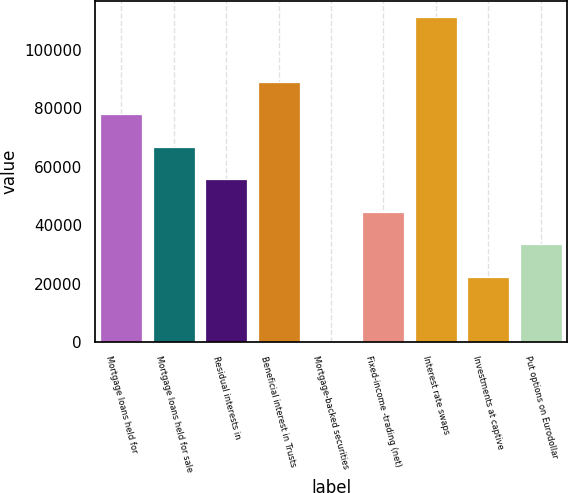Convert chart. <chart><loc_0><loc_0><loc_500><loc_500><bar_chart><fcel>Mortgage loans held for<fcel>Mortgage loans held for sale<fcel>Residual interests in<fcel>Beneficial interest in Trusts<fcel>Mortgage-backed securities<fcel>Fixed-income -trading (net)<fcel>Interest rate swaps<fcel>Investments at captive<fcel>Put options on Eurodollar<nl><fcel>77976.9<fcel>66846.2<fcel>55715.5<fcel>89107.6<fcel>62<fcel>44584.8<fcel>111369<fcel>22323.4<fcel>33454.1<nl></chart> 